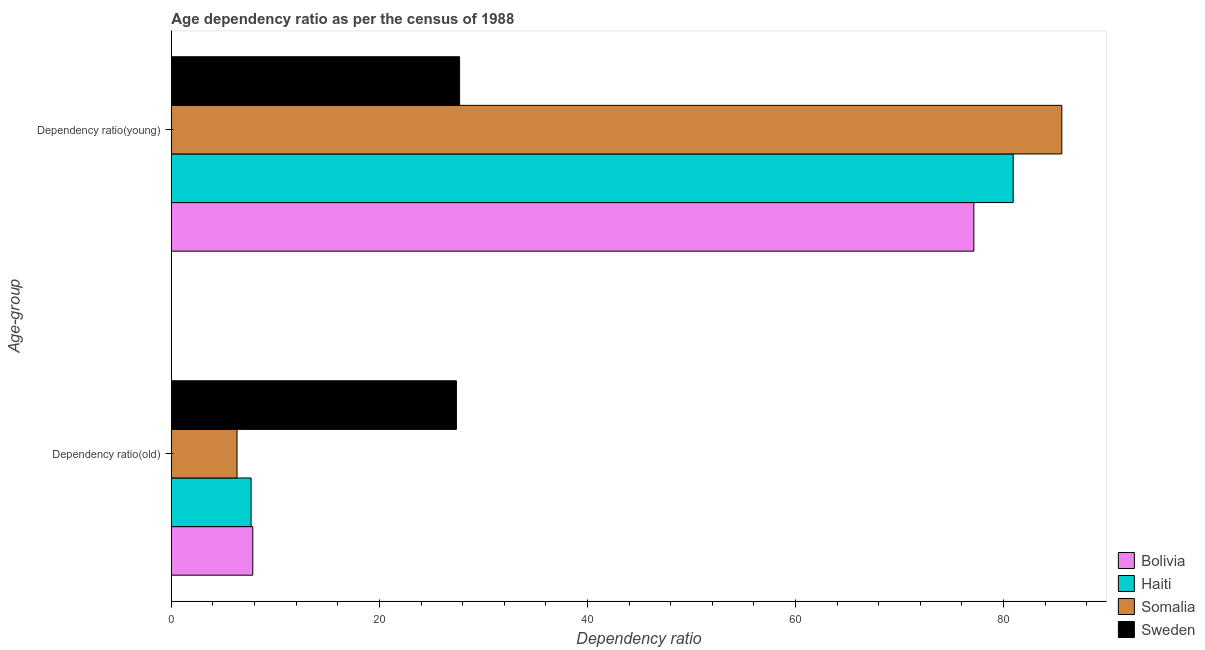How many groups of bars are there?
Your response must be concise. 2. Are the number of bars per tick equal to the number of legend labels?
Keep it short and to the point. Yes. What is the label of the 2nd group of bars from the top?
Provide a succinct answer. Dependency ratio(old). What is the age dependency ratio(old) in Haiti?
Your answer should be very brief. 7.66. Across all countries, what is the maximum age dependency ratio(old)?
Provide a succinct answer. 27.4. Across all countries, what is the minimum age dependency ratio(young)?
Provide a short and direct response. 27.71. In which country was the age dependency ratio(old) maximum?
Give a very brief answer. Sweden. What is the total age dependency ratio(young) in the graph?
Offer a terse response. 271.4. What is the difference between the age dependency ratio(old) in Bolivia and that in Sweden?
Keep it short and to the point. -19.58. What is the difference between the age dependency ratio(young) in Bolivia and the age dependency ratio(old) in Somalia?
Your response must be concise. 70.84. What is the average age dependency ratio(young) per country?
Your answer should be very brief. 67.85. What is the difference between the age dependency ratio(young) and age dependency ratio(old) in Sweden?
Ensure brevity in your answer.  0.31. In how many countries, is the age dependency ratio(young) greater than 12 ?
Your answer should be very brief. 4. What is the ratio of the age dependency ratio(old) in Bolivia to that in Somalia?
Offer a terse response. 1.24. Is the age dependency ratio(old) in Somalia less than that in Haiti?
Provide a succinct answer. Yes. What does the 3rd bar from the top in Dependency ratio(old) represents?
Ensure brevity in your answer.  Haiti. What does the 1st bar from the bottom in Dependency ratio(old) represents?
Offer a very short reply. Bolivia. How many bars are there?
Offer a terse response. 8. Are all the bars in the graph horizontal?
Keep it short and to the point. Yes. Are the values on the major ticks of X-axis written in scientific E-notation?
Your response must be concise. No. Does the graph contain any zero values?
Provide a short and direct response. No. Does the graph contain grids?
Provide a succinct answer. No. What is the title of the graph?
Your answer should be very brief. Age dependency ratio as per the census of 1988. What is the label or title of the X-axis?
Provide a short and direct response. Dependency ratio. What is the label or title of the Y-axis?
Offer a terse response. Age-group. What is the Dependency ratio in Bolivia in Dependency ratio(old)?
Provide a short and direct response. 7.83. What is the Dependency ratio of Haiti in Dependency ratio(old)?
Your answer should be compact. 7.66. What is the Dependency ratio in Somalia in Dependency ratio(old)?
Your answer should be compact. 6.31. What is the Dependency ratio of Sweden in Dependency ratio(old)?
Provide a succinct answer. 27.4. What is the Dependency ratio in Bolivia in Dependency ratio(young)?
Offer a very short reply. 77.15. What is the Dependency ratio of Haiti in Dependency ratio(young)?
Your answer should be compact. 80.93. What is the Dependency ratio of Somalia in Dependency ratio(young)?
Offer a very short reply. 85.61. What is the Dependency ratio in Sweden in Dependency ratio(young)?
Give a very brief answer. 27.71. Across all Age-group, what is the maximum Dependency ratio of Bolivia?
Ensure brevity in your answer.  77.15. Across all Age-group, what is the maximum Dependency ratio in Haiti?
Offer a very short reply. 80.93. Across all Age-group, what is the maximum Dependency ratio in Somalia?
Offer a very short reply. 85.61. Across all Age-group, what is the maximum Dependency ratio of Sweden?
Your response must be concise. 27.71. Across all Age-group, what is the minimum Dependency ratio in Bolivia?
Your answer should be compact. 7.83. Across all Age-group, what is the minimum Dependency ratio of Haiti?
Give a very brief answer. 7.66. Across all Age-group, what is the minimum Dependency ratio of Somalia?
Provide a short and direct response. 6.31. Across all Age-group, what is the minimum Dependency ratio in Sweden?
Ensure brevity in your answer.  27.4. What is the total Dependency ratio in Bolivia in the graph?
Ensure brevity in your answer.  84.98. What is the total Dependency ratio of Haiti in the graph?
Offer a very short reply. 88.6. What is the total Dependency ratio of Somalia in the graph?
Provide a short and direct response. 91.92. What is the total Dependency ratio in Sweden in the graph?
Your response must be concise. 55.11. What is the difference between the Dependency ratio of Bolivia in Dependency ratio(old) and that in Dependency ratio(young)?
Provide a short and direct response. -69.33. What is the difference between the Dependency ratio in Haiti in Dependency ratio(old) and that in Dependency ratio(young)?
Your response must be concise. -73.27. What is the difference between the Dependency ratio of Somalia in Dependency ratio(old) and that in Dependency ratio(young)?
Provide a succinct answer. -79.3. What is the difference between the Dependency ratio of Sweden in Dependency ratio(old) and that in Dependency ratio(young)?
Your answer should be very brief. -0.31. What is the difference between the Dependency ratio in Bolivia in Dependency ratio(old) and the Dependency ratio in Haiti in Dependency ratio(young)?
Your answer should be compact. -73.1. What is the difference between the Dependency ratio of Bolivia in Dependency ratio(old) and the Dependency ratio of Somalia in Dependency ratio(young)?
Offer a terse response. -77.78. What is the difference between the Dependency ratio of Bolivia in Dependency ratio(old) and the Dependency ratio of Sweden in Dependency ratio(young)?
Your answer should be very brief. -19.88. What is the difference between the Dependency ratio in Haiti in Dependency ratio(old) and the Dependency ratio in Somalia in Dependency ratio(young)?
Your answer should be very brief. -77.95. What is the difference between the Dependency ratio in Haiti in Dependency ratio(old) and the Dependency ratio in Sweden in Dependency ratio(young)?
Your answer should be very brief. -20.05. What is the difference between the Dependency ratio of Somalia in Dependency ratio(old) and the Dependency ratio of Sweden in Dependency ratio(young)?
Provide a succinct answer. -21.4. What is the average Dependency ratio in Bolivia per Age-group?
Your response must be concise. 42.49. What is the average Dependency ratio in Haiti per Age-group?
Give a very brief answer. 44.3. What is the average Dependency ratio in Somalia per Age-group?
Offer a terse response. 45.96. What is the average Dependency ratio in Sweden per Age-group?
Ensure brevity in your answer.  27.56. What is the difference between the Dependency ratio of Bolivia and Dependency ratio of Haiti in Dependency ratio(old)?
Make the answer very short. 0.16. What is the difference between the Dependency ratio in Bolivia and Dependency ratio in Somalia in Dependency ratio(old)?
Give a very brief answer. 1.52. What is the difference between the Dependency ratio in Bolivia and Dependency ratio in Sweden in Dependency ratio(old)?
Provide a succinct answer. -19.58. What is the difference between the Dependency ratio in Haiti and Dependency ratio in Somalia in Dependency ratio(old)?
Your response must be concise. 1.35. What is the difference between the Dependency ratio in Haiti and Dependency ratio in Sweden in Dependency ratio(old)?
Keep it short and to the point. -19.74. What is the difference between the Dependency ratio in Somalia and Dependency ratio in Sweden in Dependency ratio(old)?
Offer a very short reply. -21.09. What is the difference between the Dependency ratio of Bolivia and Dependency ratio of Haiti in Dependency ratio(young)?
Your response must be concise. -3.78. What is the difference between the Dependency ratio in Bolivia and Dependency ratio in Somalia in Dependency ratio(young)?
Your response must be concise. -8.46. What is the difference between the Dependency ratio of Bolivia and Dependency ratio of Sweden in Dependency ratio(young)?
Provide a short and direct response. 49.44. What is the difference between the Dependency ratio in Haiti and Dependency ratio in Somalia in Dependency ratio(young)?
Your answer should be very brief. -4.68. What is the difference between the Dependency ratio of Haiti and Dependency ratio of Sweden in Dependency ratio(young)?
Ensure brevity in your answer.  53.22. What is the difference between the Dependency ratio in Somalia and Dependency ratio in Sweden in Dependency ratio(young)?
Keep it short and to the point. 57.9. What is the ratio of the Dependency ratio in Bolivia in Dependency ratio(old) to that in Dependency ratio(young)?
Keep it short and to the point. 0.1. What is the ratio of the Dependency ratio in Haiti in Dependency ratio(old) to that in Dependency ratio(young)?
Ensure brevity in your answer.  0.09. What is the ratio of the Dependency ratio in Somalia in Dependency ratio(old) to that in Dependency ratio(young)?
Offer a terse response. 0.07. What is the ratio of the Dependency ratio of Sweden in Dependency ratio(old) to that in Dependency ratio(young)?
Provide a short and direct response. 0.99. What is the difference between the highest and the second highest Dependency ratio in Bolivia?
Ensure brevity in your answer.  69.33. What is the difference between the highest and the second highest Dependency ratio of Haiti?
Offer a terse response. 73.27. What is the difference between the highest and the second highest Dependency ratio in Somalia?
Provide a succinct answer. 79.3. What is the difference between the highest and the second highest Dependency ratio in Sweden?
Ensure brevity in your answer.  0.31. What is the difference between the highest and the lowest Dependency ratio in Bolivia?
Your answer should be very brief. 69.33. What is the difference between the highest and the lowest Dependency ratio of Haiti?
Provide a short and direct response. 73.27. What is the difference between the highest and the lowest Dependency ratio in Somalia?
Provide a succinct answer. 79.3. What is the difference between the highest and the lowest Dependency ratio of Sweden?
Make the answer very short. 0.31. 